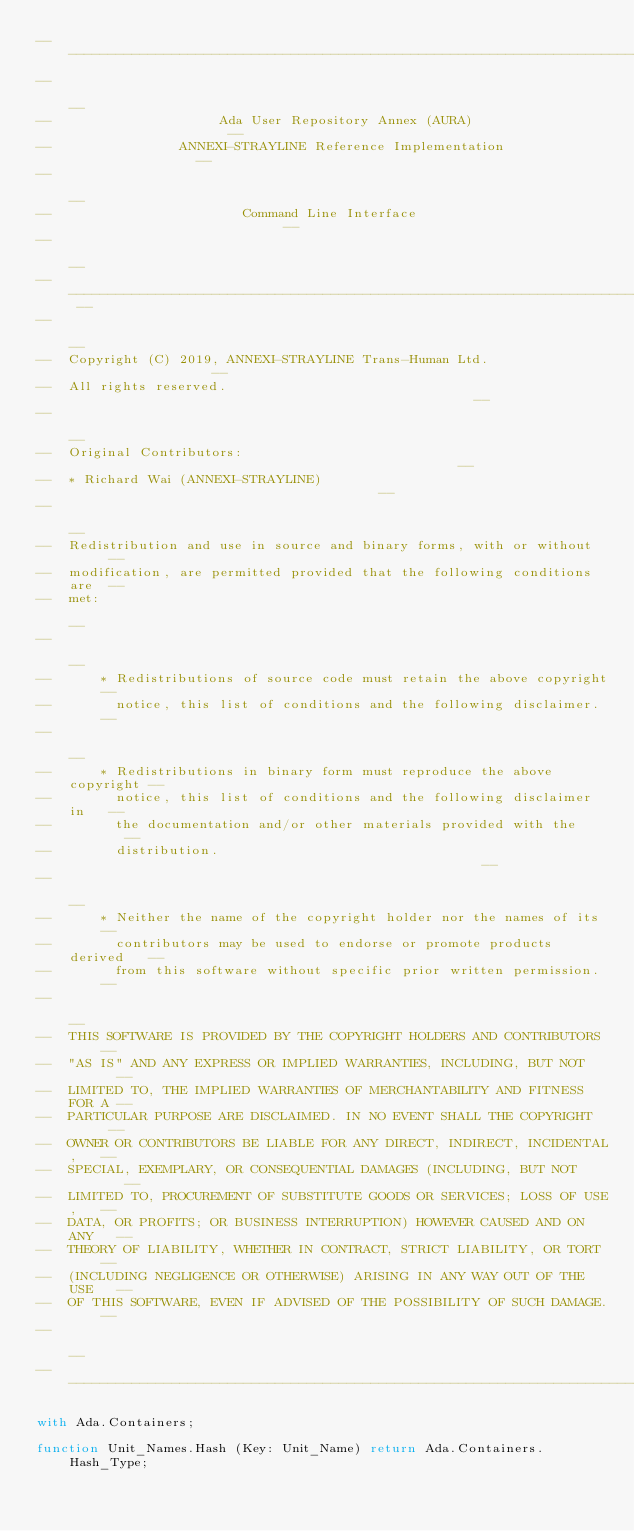Convert code to text. <code><loc_0><loc_0><loc_500><loc_500><_Ada_>------------------------------------------------------------------------------
--                                                                          --
--                     Ada User Repository Annex (AURA)                     --
--                ANNEXI-STRAYLINE Reference Implementation                 --
--                                                                          --
--                        Command Line Interface                            --
--                                                                          --
-- ------------------------------------------------------------------------ --
--                                                                          --
--  Copyright (C) 2019, ANNEXI-STRAYLINE Trans-Human Ltd.                   --
--  All rights reserved.                                                    --
--                                                                          --
--  Original Contributors:                                                  --
--  * Richard Wai (ANNEXI-STRAYLINE)                                        --
--                                                                          --
--  Redistribution and use in source and binary forms, with or without      --
--  modification, are permitted provided that the following conditions are  --
--  met:                                                                    --
--                                                                          --
--      * Redistributions of source code must retain the above copyright    --
--        notice, this list of conditions and the following disclaimer.     --
--                                                                          --
--      * Redistributions in binary form must reproduce the above copyright --
--        notice, this list of conditions and the following disclaimer in   --
--        the documentation and/or other materials provided with the        --
--        distribution.                                                     --
--                                                                          --
--      * Neither the name of the copyright holder nor the names of its     --
--        contributors may be used to endorse or promote products derived   --
--        from this software without specific prior written permission.     --
--                                                                          --
--  THIS SOFTWARE IS PROVIDED BY THE COPYRIGHT HOLDERS AND CONTRIBUTORS     --
--  "AS IS" AND ANY EXPRESS OR IMPLIED WARRANTIES, INCLUDING, BUT NOT       --
--  LIMITED TO, THE IMPLIED WARRANTIES OF MERCHANTABILITY AND FITNESS FOR A --
--  PARTICULAR PURPOSE ARE DISCLAIMED. IN NO EVENT SHALL THE COPYRIGHT      --
--  OWNER OR CONTRIBUTORS BE LIABLE FOR ANY DIRECT, INDIRECT, INCIDENTAL,   --
--  SPECIAL, EXEMPLARY, OR CONSEQUENTIAL DAMAGES (INCLUDING, BUT NOT        --
--  LIMITED TO, PROCUREMENT OF SUBSTITUTE GOODS OR SERVICES; LOSS OF USE,   --
--  DATA, OR PROFITS; OR BUSINESS INTERRUPTION) HOWEVER CAUSED AND ON ANY   --
--  THEORY OF LIABILITY, WHETHER IN CONTRACT, STRICT LIABILITY, OR TORT     --
--  (INCLUDING NEGLIGENCE OR OTHERWISE) ARISING IN ANY WAY OUT OF THE USE   --
--  OF THIS SOFTWARE, EVEN IF ADVISED OF THE POSSIBILITY OF SUCH DAMAGE.    --
--                                                                          --
------------------------------------------------------------------------------

with Ada.Containers;

function Unit_Names.Hash (Key: Unit_Name) return Ada.Containers.Hash_Type;
</code> 